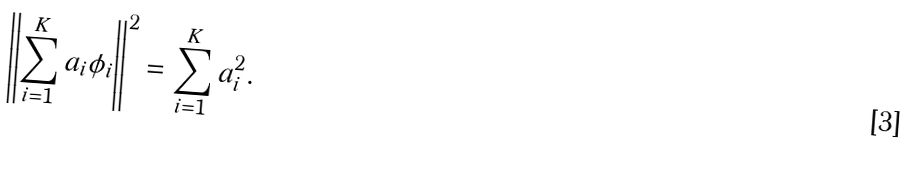Convert formula to latex. <formula><loc_0><loc_0><loc_500><loc_500>\left \| \sum _ { i = 1 } ^ { K } a _ { i } \phi _ { i } \right \| ^ { 2 } = \sum _ { i = 1 } ^ { K } a _ { i } ^ { 2 } .</formula> 